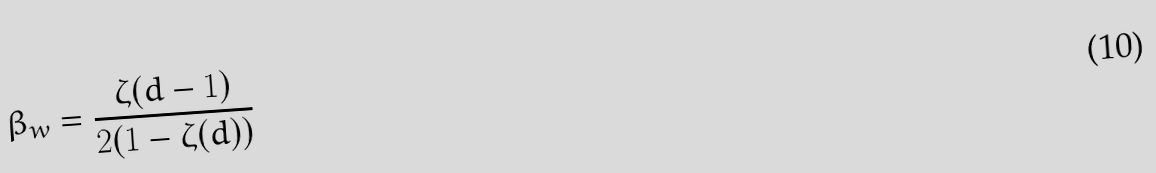Convert formula to latex. <formula><loc_0><loc_0><loc_500><loc_500>\beta _ { w } = \frac { \zeta ( d - 1 ) } { 2 ( 1 - \zeta ( d ) ) }</formula> 